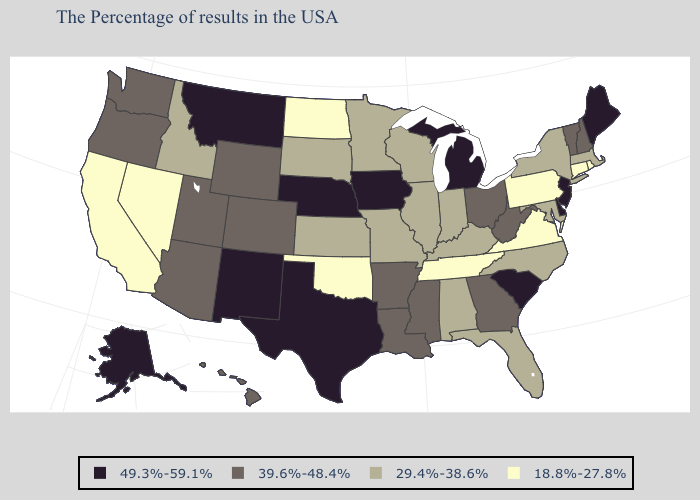What is the lowest value in the USA?
Give a very brief answer. 18.8%-27.8%. Name the states that have a value in the range 18.8%-27.8%?
Keep it brief. Rhode Island, Connecticut, Pennsylvania, Virginia, Tennessee, Oklahoma, North Dakota, Nevada, California. Does South Dakota have a lower value than West Virginia?
Write a very short answer. Yes. Does Arizona have the highest value in the USA?
Short answer required. No. How many symbols are there in the legend?
Give a very brief answer. 4. Does Illinois have the lowest value in the MidWest?
Write a very short answer. No. What is the highest value in the USA?
Give a very brief answer. 49.3%-59.1%. Does New Jersey have a higher value than Maine?
Short answer required. No. Does Oklahoma have the same value as Nebraska?
Answer briefly. No. Does the first symbol in the legend represent the smallest category?
Write a very short answer. No. What is the value of Pennsylvania?
Keep it brief. 18.8%-27.8%. What is the value of West Virginia?
Quick response, please. 39.6%-48.4%. Name the states that have a value in the range 39.6%-48.4%?
Short answer required. New Hampshire, Vermont, West Virginia, Ohio, Georgia, Mississippi, Louisiana, Arkansas, Wyoming, Colorado, Utah, Arizona, Washington, Oregon, Hawaii. What is the value of South Carolina?
Answer briefly. 49.3%-59.1%. Name the states that have a value in the range 49.3%-59.1%?
Quick response, please. Maine, New Jersey, Delaware, South Carolina, Michigan, Iowa, Nebraska, Texas, New Mexico, Montana, Alaska. 